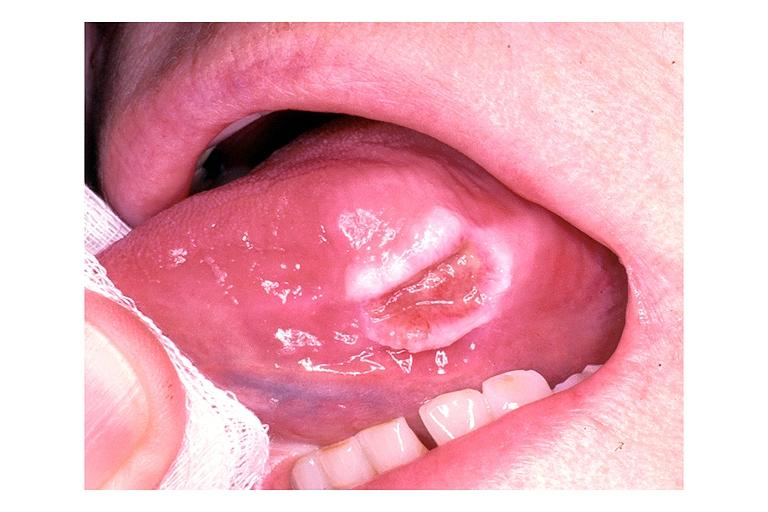does hepatobiliary show traumatic ulcer?
Answer the question using a single word or phrase. No 